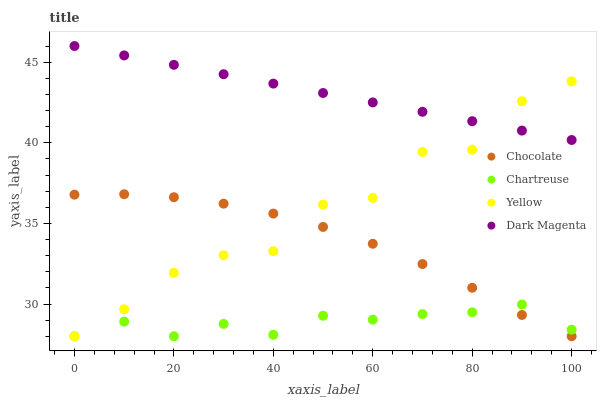Does Chartreuse have the minimum area under the curve?
Answer yes or no. Yes. Does Dark Magenta have the maximum area under the curve?
Answer yes or no. Yes. Does Yellow have the minimum area under the curve?
Answer yes or no. No. Does Yellow have the maximum area under the curve?
Answer yes or no. No. Is Dark Magenta the smoothest?
Answer yes or no. Yes. Is Yellow the roughest?
Answer yes or no. Yes. Is Yellow the smoothest?
Answer yes or no. No. Is Dark Magenta the roughest?
Answer yes or no. No. Does Chartreuse have the lowest value?
Answer yes or no. Yes. Does Dark Magenta have the lowest value?
Answer yes or no. No. Does Dark Magenta have the highest value?
Answer yes or no. Yes. Does Yellow have the highest value?
Answer yes or no. No. Is Chartreuse less than Dark Magenta?
Answer yes or no. Yes. Is Dark Magenta greater than Chocolate?
Answer yes or no. Yes. Does Yellow intersect Chartreuse?
Answer yes or no. Yes. Is Yellow less than Chartreuse?
Answer yes or no. No. Is Yellow greater than Chartreuse?
Answer yes or no. No. Does Chartreuse intersect Dark Magenta?
Answer yes or no. No. 